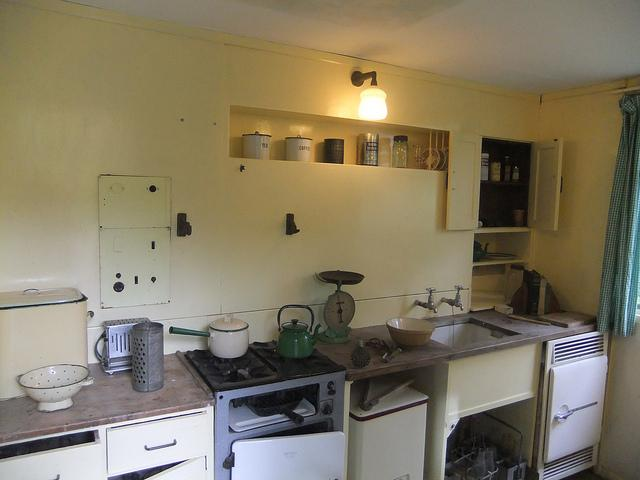What is the white bowl with holes in it on the left used for? straining 